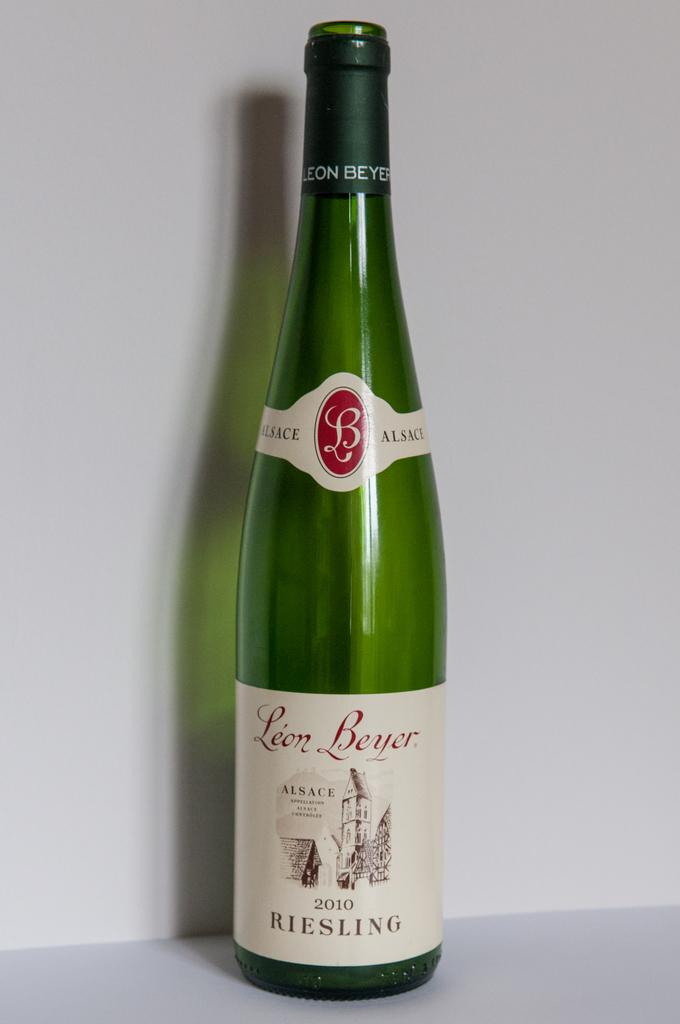<image>
Give a short and clear explanation of the subsequent image. A bottle of Leon Beyer 2010 REISLING sits by itself. 